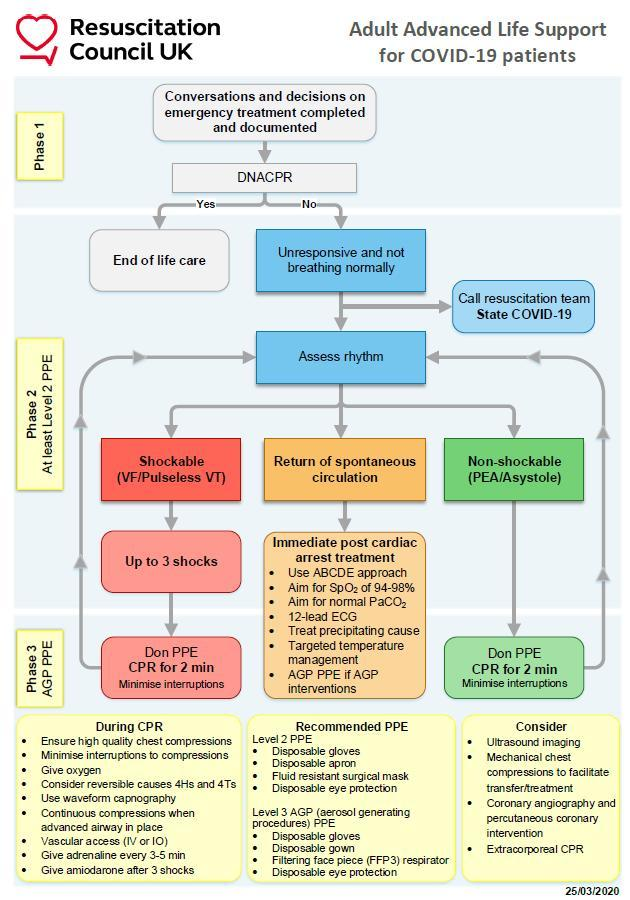What are the procedures to be done when the Covid 19 patient is Unresponsive and not breathing normally?
Answer the question with a short phrase. Assess rhythm, Call Resuscitation team state COVID-19 What happens when DNACPR for a COVID-19 patient is marked as "Yes"? End of life Care What happens to a COVID-19 patient when DNACPR  is marked as "No"? Unresponsive and not breathing normally 